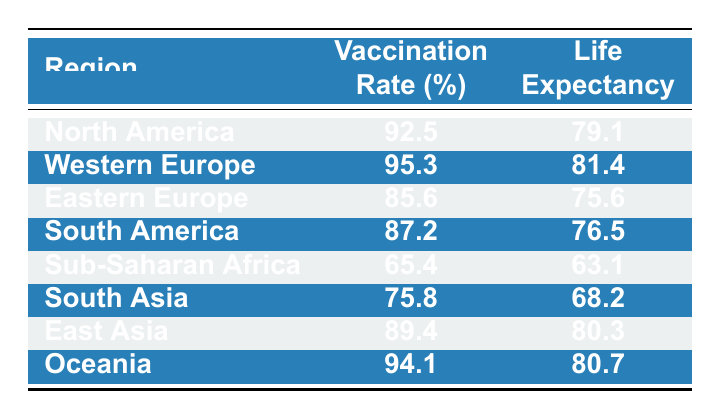What is the vaccination rate in Western Europe? The table directly lists the vaccination rate for each region. According to the table, the vaccination rate for Western Europe is 95.3%.
Answer: 95.3 Which region has the lowest life expectancy? By examining the life expectancy values in the table, Sub-Saharan Africa has the lowest life expectancy at 63.1 years.
Answer: Sub-Saharan Africa What is the difference in life expectancy between North America and South America? The life expectancy for North America is 79.1 years, while South America’s life expectancy is 76.5 years. The difference is 79.1 - 76.5 = 2.6 years.
Answer: 2.6 Is the vaccination rate in Eastern Europe greater than 80%? According to the table, Eastern Europe has a vaccination rate of 85.6%, which is indeed greater than 80%.
Answer: Yes What is the average vaccination rate for all regions listed? To find the average, we sum all the vaccination rates: 92.5 + 95.3 + 85.6 + 87.2 + 65.4 + 75.8 + 89.4 + 94.1 = 705.9. There are 8 regions, so the average is 705.9 / 8 = 88.24.
Answer: 88.24 Which region has a life expectancy greater than 80 years and a vaccination rate below 90%? From the table, the region that meets these conditions is East Asia, with a life expectancy of 80.3 years and a vaccination rate of 89.4%.
Answer: East Asia How many regions have both a vaccination rate above 90% and a life expectancy of 80 years or higher? The regions that meet these criteria are Western Europe (95.3% and 81.4 years), North America (92.5% and 79.1 years), Oceania (94.1% and 80.7 years), and East Asia (89.4% and 80.3 years). The two regions are Western Europe and Oceania. Therefore, there are two such regions.
Answer: 2 Is it true that South Asia has a higher life expectancy than Sub-Saharan Africa? The life expectancy for South Asia is 68.2 years and for Sub-Saharan Africa, it is 63.1 years. Since 68.2 is greater than 63.1, the statement is true.
Answer: Yes 